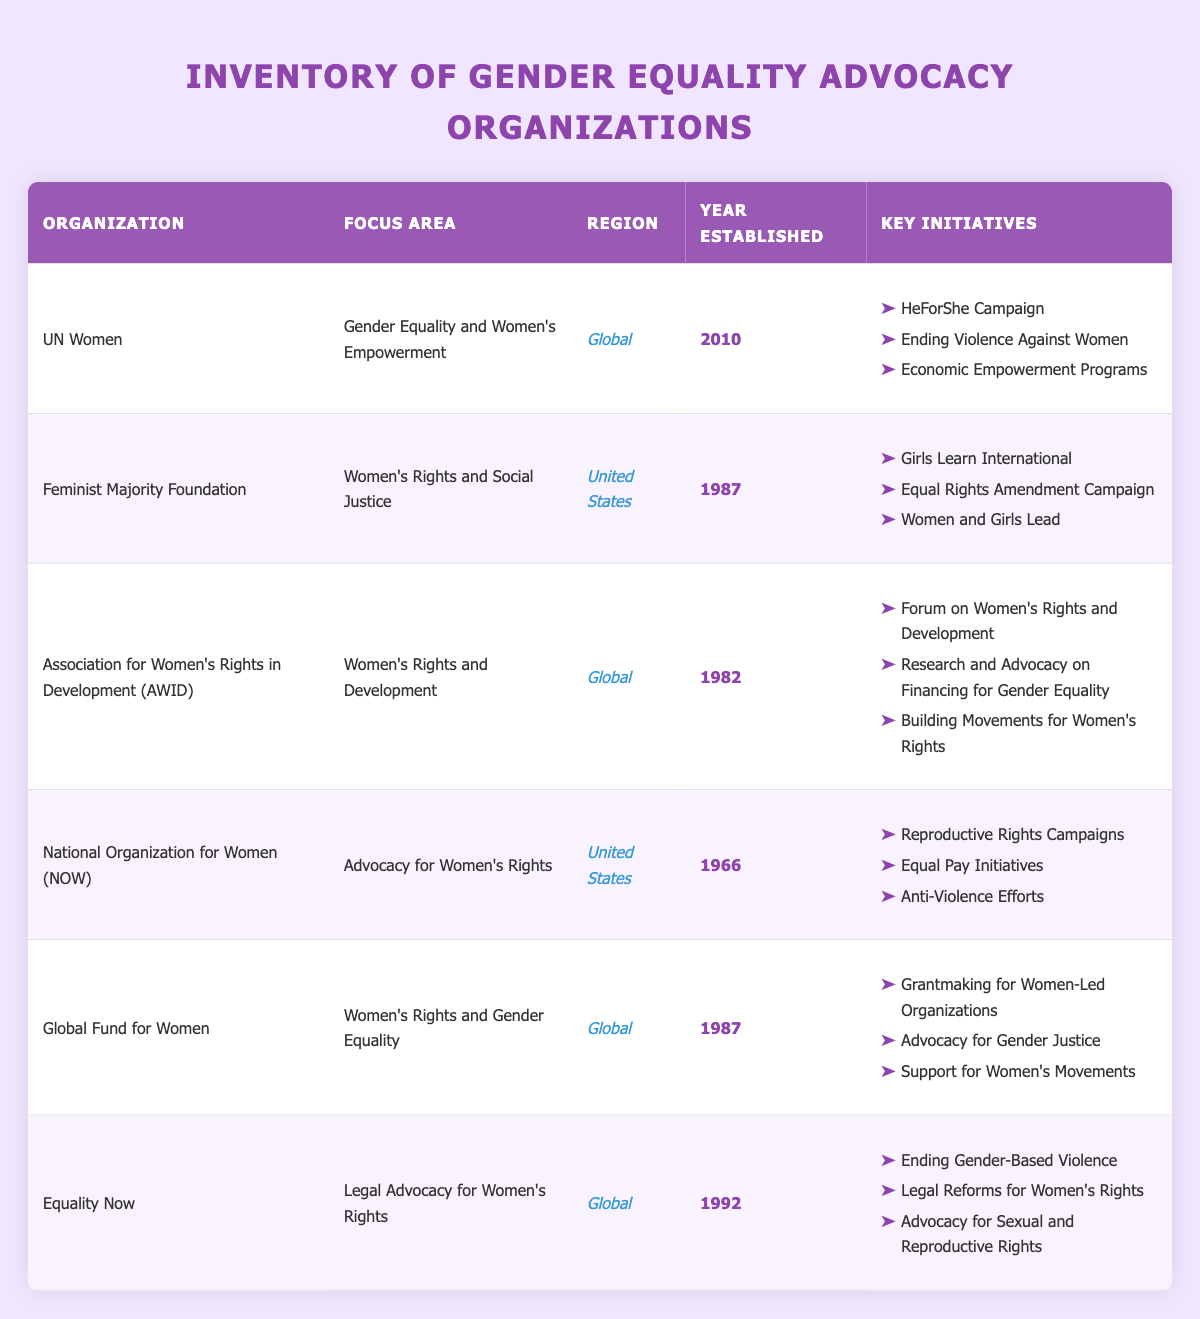What is the focus area of UN Women? According to the table, UN Women's focus area is listed as "Gender Equality and Women's Empowerment." This information can be retrieved directly from the relevant row in the table.
Answer: Gender Equality and Women's Empowerment Which organization was established first, NOW or AWID? The table indicates that the National Organization for Women (NOW) was established in 1966, whereas the Association for Women's Rights in Development (AWID) was established in 1982. To find out which was established first, we just compare these years.
Answer: NOW How many organizations focus on Global regions? The table shows that there are four organizations identified with a "Global" region: UN Women, AWID, Global Fund for Women, and Equality Now. By counting these entries, we can determine how many focus globally.
Answer: Four Do any organizations focus on legal advocacy for women's rights? From the table, we see that Equality Now is the only organization that specifically lists "Legal Advocacy for Women's Rights" as its focus area, confirming that this is true.
Answer: Yes What initiatives are listed for the Feminist Majority Foundation? The key initiatives for the Feminist Majority Foundation, as per the table, include "Girls Learn International," "Equal Rights Amendment Campaign," and "Women and Girls Lead." This information is collected from the specific row dedicated to this organization.
Answer: Girls Learn International, Equal Rights Amendment Campaign, Women and Girls Lead If we compare the year established for Global Fund for Women and Feminist Majority Foundation, who was established more recently? The Global Fund for Women was established in 1987, while the Feminist Majority Foundation was also established in 1987. Since both organizations share the same year, neither was established more recently than the other when compared.
Answer: Neither Are there any organizations focusing specifically on Economic Empowerment? By examining the table's focus areas, it is clear that UN Women mentions "Economic Empowerment Programs" among its key initiatives, which indicates the organization focuses on this area. Thus, the answer is true.
Answer: Yes What is the average year of establishment for the organizations listed? To find the average year of establishment, we list all the years (2010, 1987, 1982, 1966, 1987, 1992), sum them up (2010 + 1987 + 1982 + 1966 + 1987 + 1992 = 11924), and divide by the number of organizations (6): 11924 / 6 = 1987.33. The average rounded year is thus 1987.
Answer: 1987 Which organization has the most key initiatives? By examining the number of key initiatives for each organization, we see that both the National Organization for Women (NOW) and the Association for Women's Rights in Development (AWID) have 3 initiatives listed. Since the number is the same for both organizations, they share the title for the most key initiatives.
Answer: NOW and AWID 